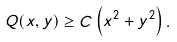Convert formula to latex. <formula><loc_0><loc_0><loc_500><loc_500>Q ( x , y ) \geq C \left ( x ^ { 2 } + y ^ { 2 } \right ) .</formula> 